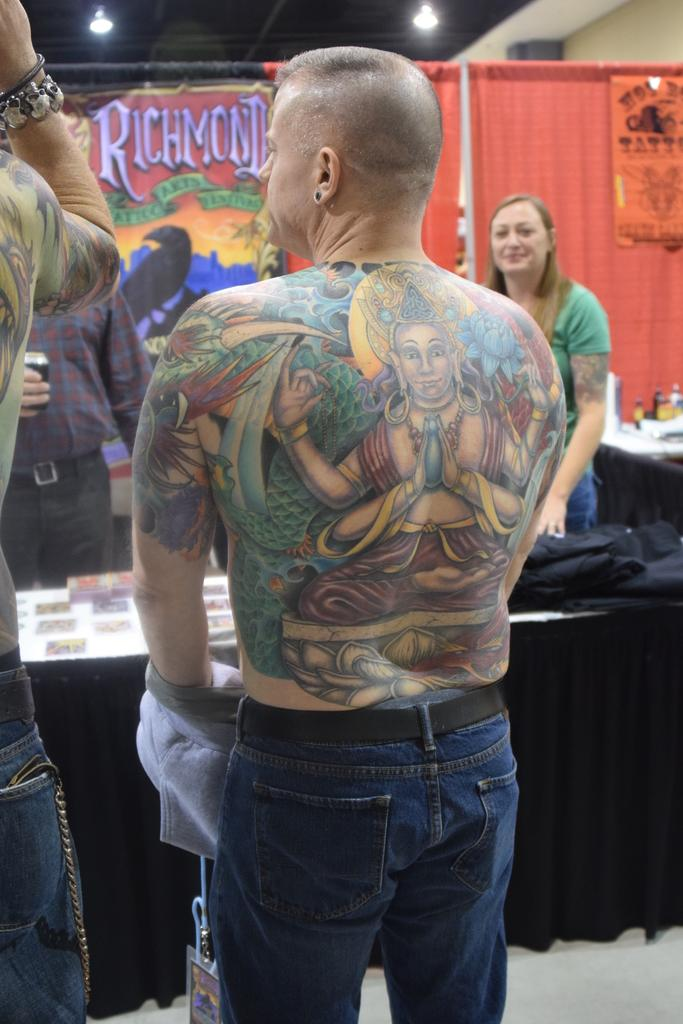How many people are in the image? There are people in the image, but the exact number cannot be determined from the provided facts. What is the main piece of furniture in the image? There is a table in the image. What can be seen on the table? There are objects placed on the table. What can be seen in the background of the image? There are curtains and a board visible in the background of the image. What is visible at the top of the image? There are lights visible at the top of the image. What type of summer activity is taking place in the image? The provided facts do not mention any season or activity, so it cannot be determined if a summer activity is taking place in the image. Is there a jail visible in the image? There is no mention of a jail or any related elements in the provided facts, so it cannot be determined if a jail is visible in the image. 